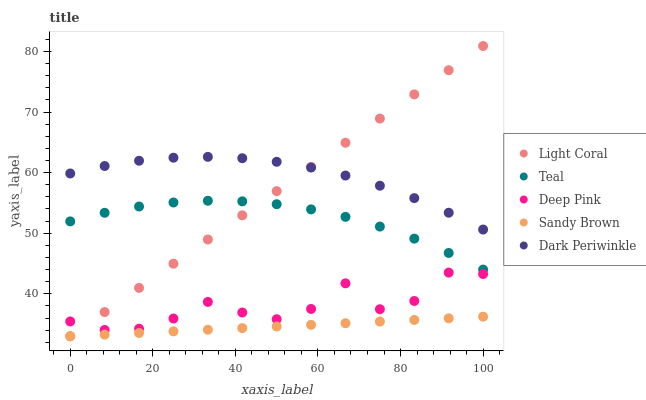Does Sandy Brown have the minimum area under the curve?
Answer yes or no. Yes. Does Dark Periwinkle have the maximum area under the curve?
Answer yes or no. Yes. Does Deep Pink have the minimum area under the curve?
Answer yes or no. No. Does Deep Pink have the maximum area under the curve?
Answer yes or no. No. Is Sandy Brown the smoothest?
Answer yes or no. Yes. Is Deep Pink the roughest?
Answer yes or no. Yes. Is Deep Pink the smoothest?
Answer yes or no. No. Is Sandy Brown the roughest?
Answer yes or no. No. Does Light Coral have the lowest value?
Answer yes or no. Yes. Does Deep Pink have the lowest value?
Answer yes or no. No. Does Light Coral have the highest value?
Answer yes or no. Yes. Does Deep Pink have the highest value?
Answer yes or no. No. Is Sandy Brown less than Teal?
Answer yes or no. Yes. Is Dark Periwinkle greater than Teal?
Answer yes or no. Yes. Does Dark Periwinkle intersect Light Coral?
Answer yes or no. Yes. Is Dark Periwinkle less than Light Coral?
Answer yes or no. No. Is Dark Periwinkle greater than Light Coral?
Answer yes or no. No. Does Sandy Brown intersect Teal?
Answer yes or no. No. 